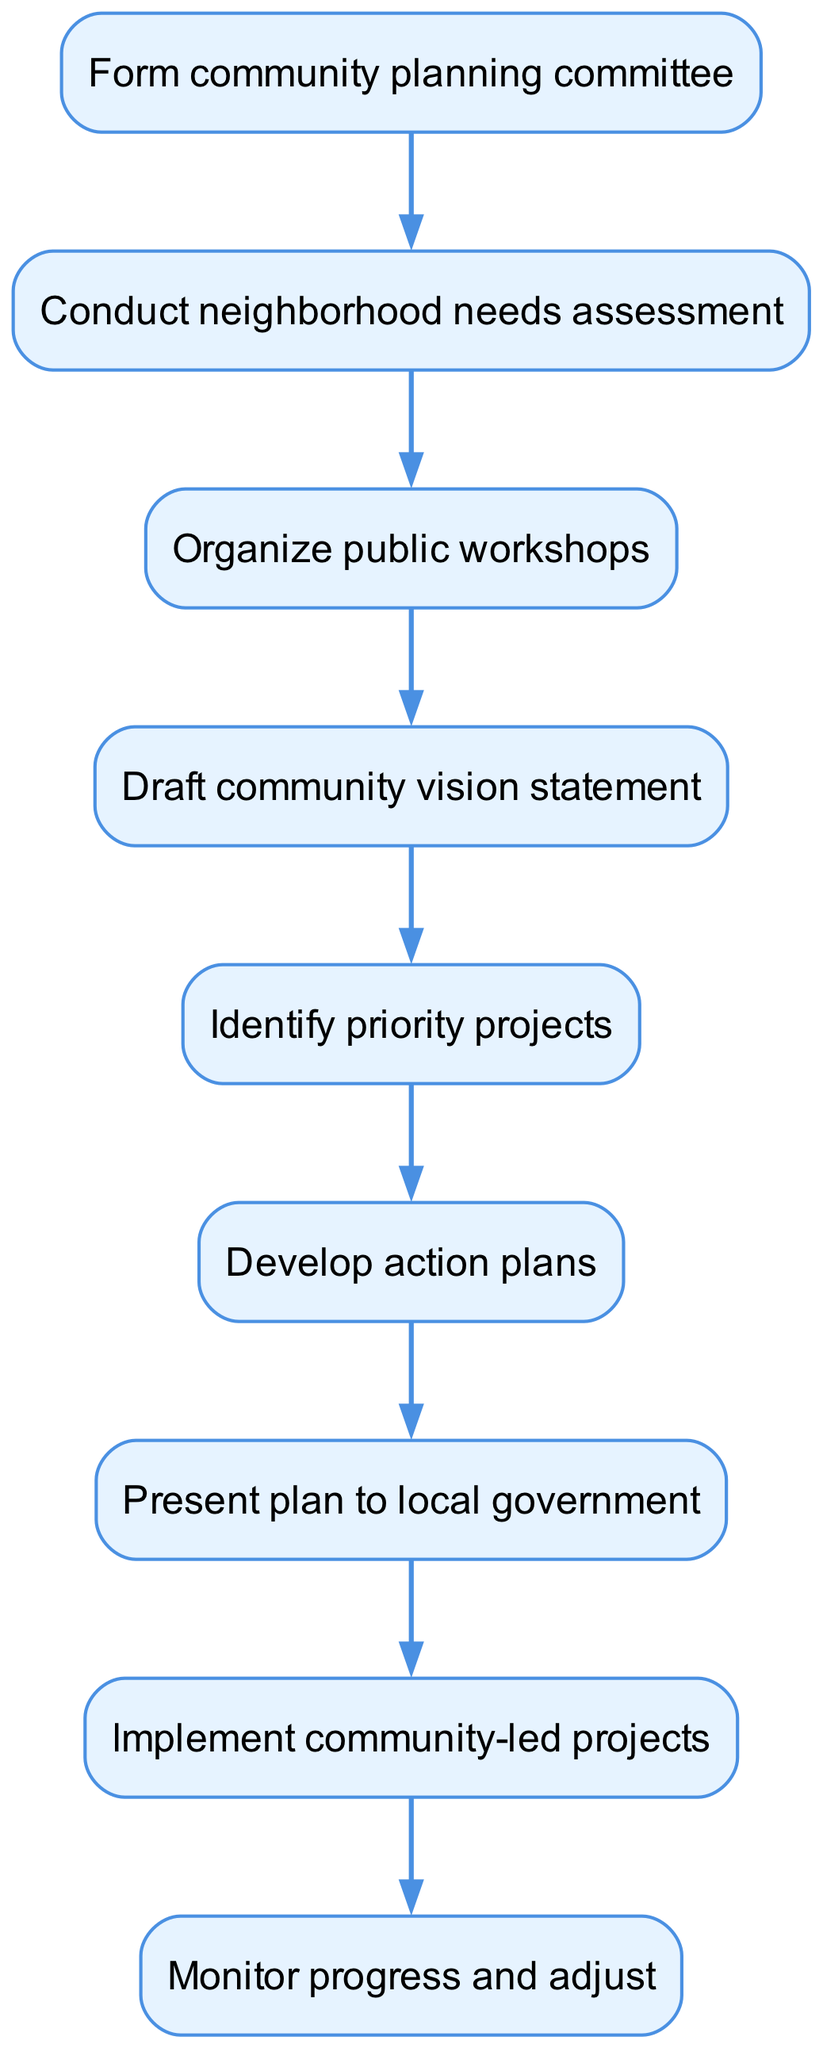What is the first step in the initiative? The first step is represented as the starting node of the flow chart, which is to "Form community planning committee".
Answer: Form community planning committee How many total steps are in the process? The diagram lists a total of 9 steps, each represented by a node.
Answer: 9 What is the last step of the initiative? The last step is identified as "Monitor progress and adjust", which is the final node with no subsequent steps.
Answer: Monitor progress and adjust Which step comes after "Draft community vision statement"? Following "Draft community vision statement", the next step indicated in the diagram is "Identify priority projects".
Answer: Identify priority projects What is the relationship between "Present plan to local government" and "Implement community-led projects"? The flow from "Present plan to local government" to "Implement community-led projects" indicates that presenting the plan is a prerequisite before implementing the projects.
Answer: Prerequisite If the needs assessment is not conducted, which step would be skipped? If "Conduct neighborhood needs assessment" is not performed, the subsequent step "Organize public workshops" would be skipped as it's dependent on the previous step.
Answer: Organize public workshops What action follows the identification of priority projects? After identifying priority projects, the next action is to "Develop action plans", as indicated by the flow of the diagram.
Answer: Develop action plans How does the diagram illustrate the concept of community-led initiatives? The diagram is structured to demonstrate a step-by-step process where each phase is community-driven, emphasizing engagement in urban planning, culminating in implementation by the community.
Answer: Community-driven process 